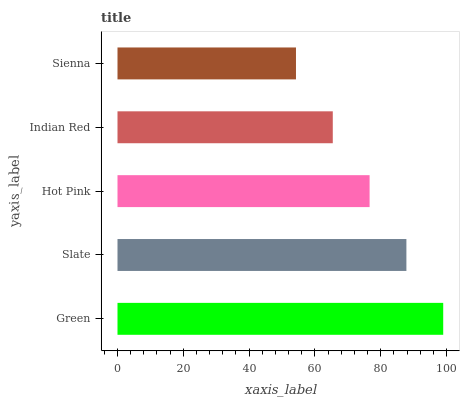Is Sienna the minimum?
Answer yes or no. Yes. Is Green the maximum?
Answer yes or no. Yes. Is Slate the minimum?
Answer yes or no. No. Is Slate the maximum?
Answer yes or no. No. Is Green greater than Slate?
Answer yes or no. Yes. Is Slate less than Green?
Answer yes or no. Yes. Is Slate greater than Green?
Answer yes or no. No. Is Green less than Slate?
Answer yes or no. No. Is Hot Pink the high median?
Answer yes or no. Yes. Is Hot Pink the low median?
Answer yes or no. Yes. Is Green the high median?
Answer yes or no. No. Is Sienna the low median?
Answer yes or no. No. 